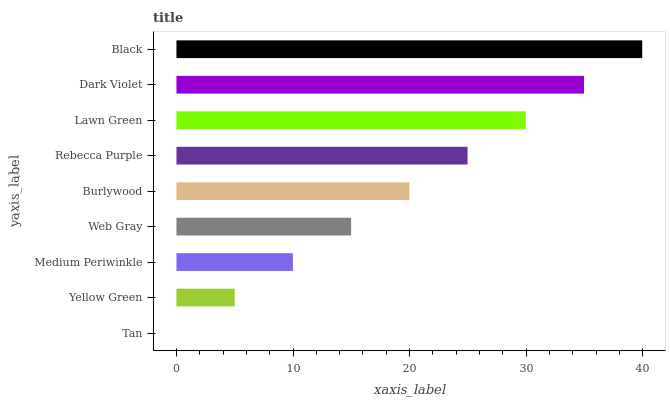Is Tan the minimum?
Answer yes or no. Yes. Is Black the maximum?
Answer yes or no. Yes. Is Yellow Green the minimum?
Answer yes or no. No. Is Yellow Green the maximum?
Answer yes or no. No. Is Yellow Green greater than Tan?
Answer yes or no. Yes. Is Tan less than Yellow Green?
Answer yes or no. Yes. Is Tan greater than Yellow Green?
Answer yes or no. No. Is Yellow Green less than Tan?
Answer yes or no. No. Is Burlywood the high median?
Answer yes or no. Yes. Is Burlywood the low median?
Answer yes or no. Yes. Is Lawn Green the high median?
Answer yes or no. No. Is Yellow Green the low median?
Answer yes or no. No. 